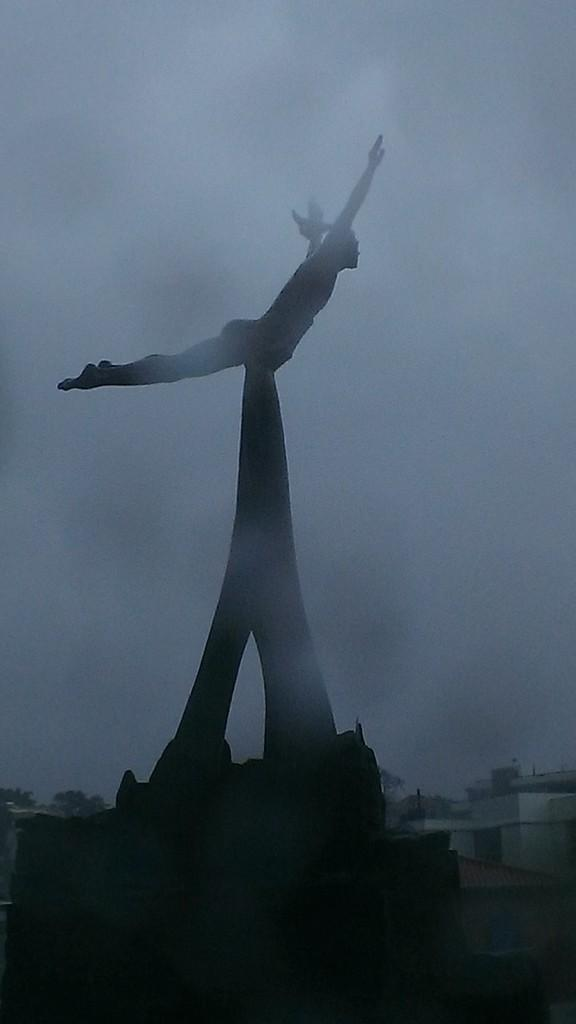What is the main subject in the image? There is a statue in the image. What can be seen in the background of the image? The sky is visible in the background of the image. What is located at the bottom of the image? There are houses and trees at the bottom of the image. How does the boy use friction to perform a trick with the statue in the image? There is no boy present in the image, and therefore no trick involving friction can be observed. 